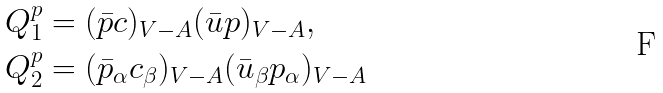<formula> <loc_0><loc_0><loc_500><loc_500>Q _ { 1 } ^ { p } & = ( \bar { p } c ) _ { V - A } ( \bar { u } p ) _ { V - A } , \\ Q _ { 2 } ^ { p } & = ( \bar { p } _ { \alpha } c _ { \beta } ) _ { V - A } ( \bar { u } _ { \beta } p _ { \alpha } ) _ { V - A }</formula> 